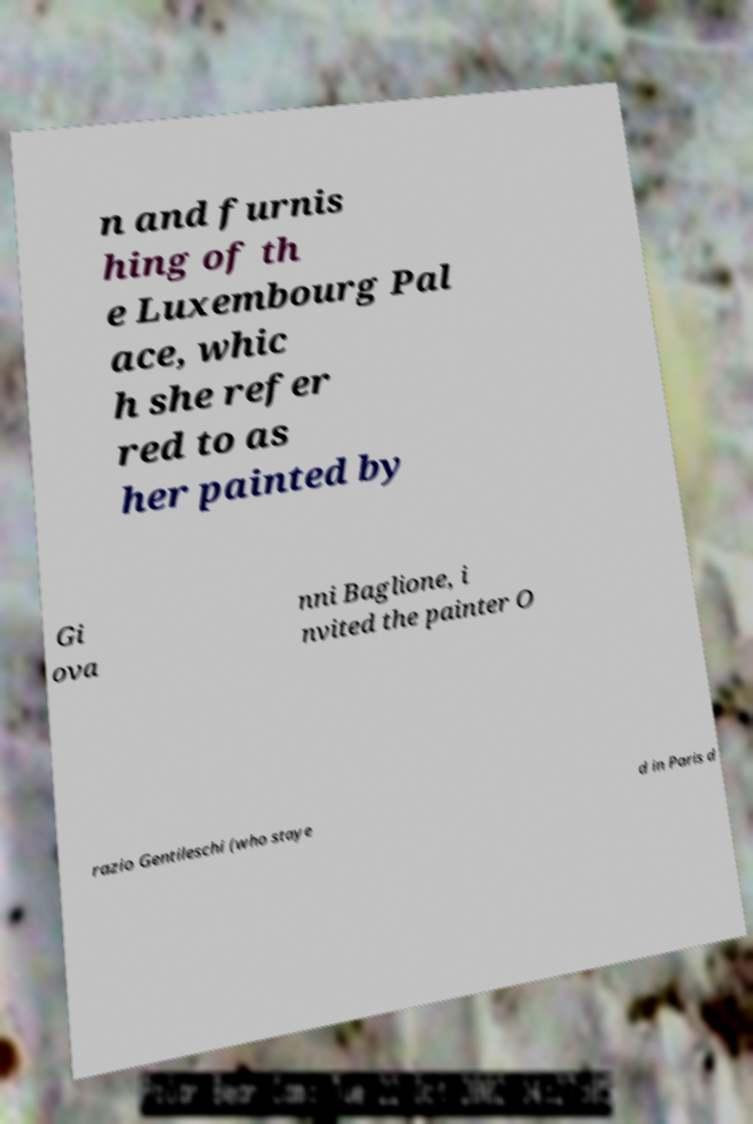Can you accurately transcribe the text from the provided image for me? n and furnis hing of th e Luxembourg Pal ace, whic h she refer red to as her painted by Gi ova nni Baglione, i nvited the painter O razio Gentileschi (who staye d in Paris d 